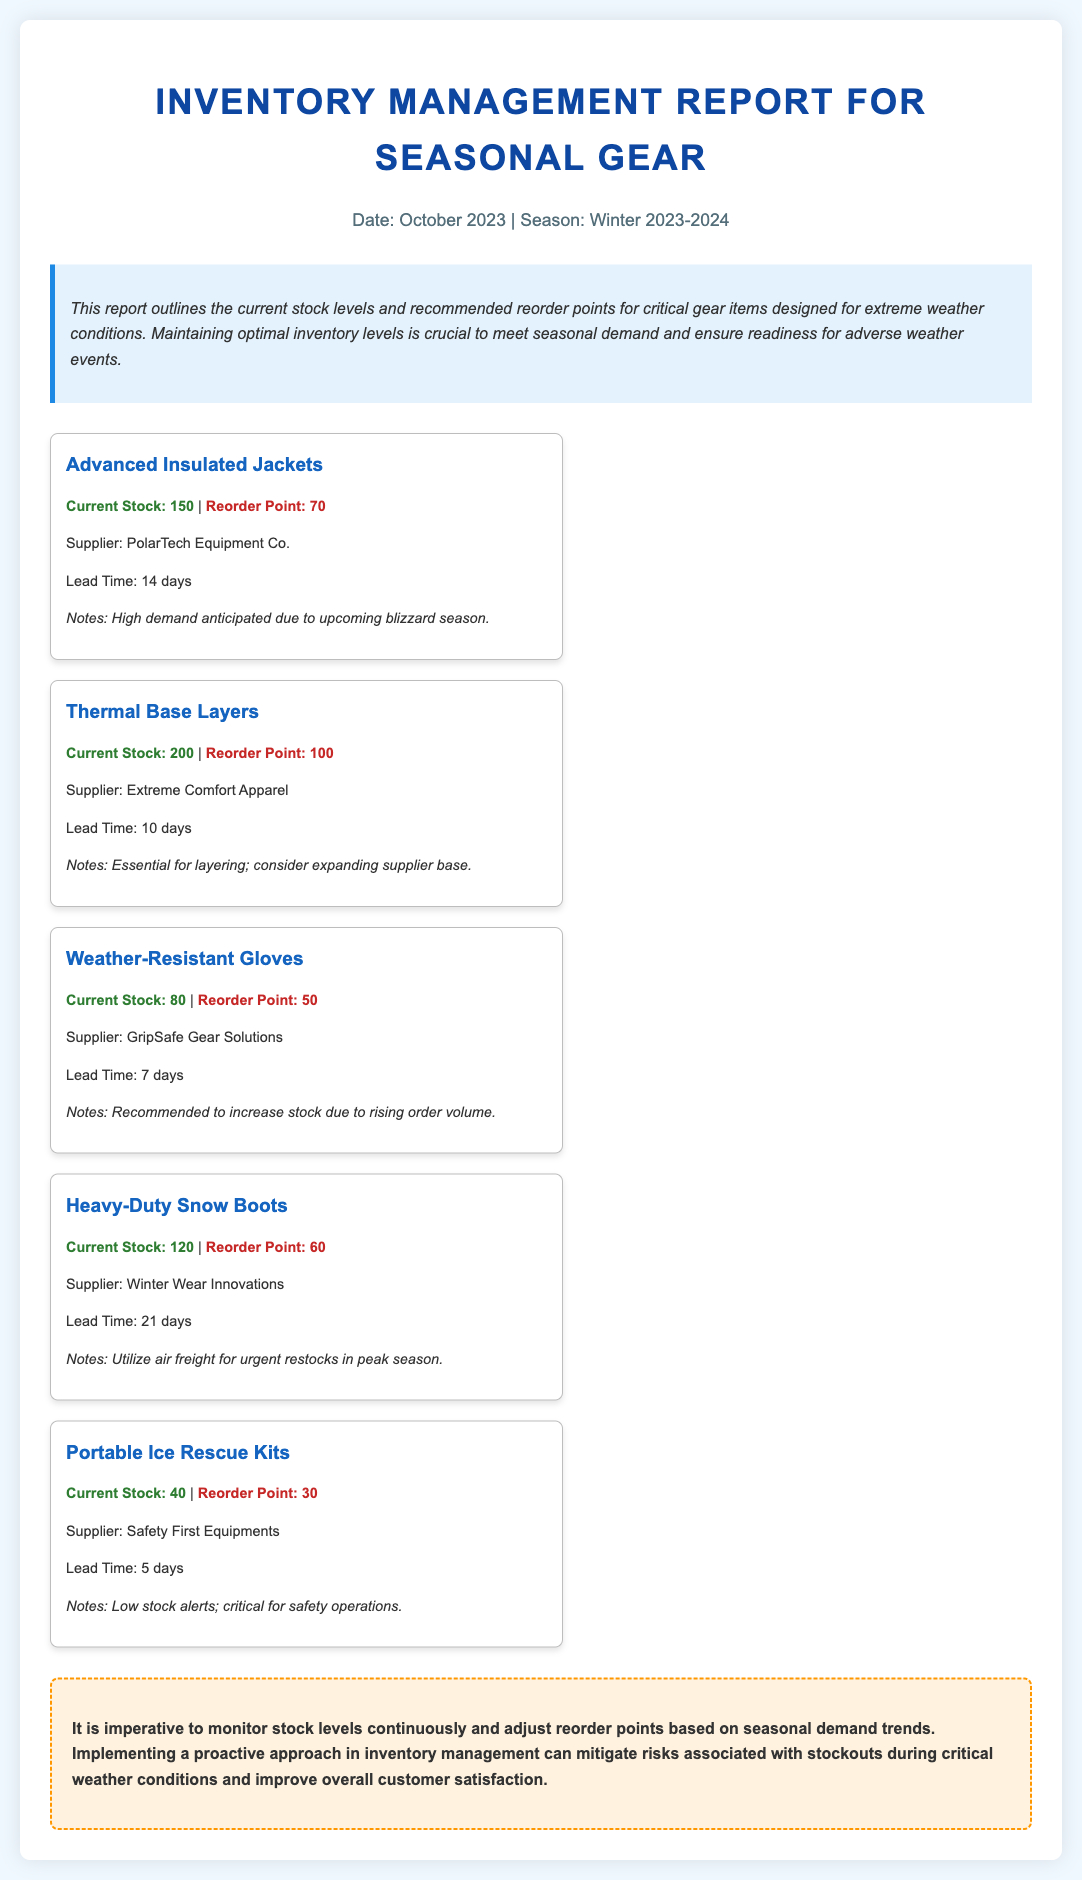what is the date of the report? The report was created in October 2023.
Answer: October 2023 what is the stock level for Advanced Insulated Jackets? The current stock level for Advanced Insulated Jackets is provided in the document.
Answer: 150 what is the reorder point for Portable Ice Rescue Kits? The reorder point for Portable Ice Rescue Kits is specified in the report.
Answer: 30 which supplier provides Thermal Base Layers? The document lists the supplier for Thermal Base Layers.
Answer: Extreme Comfort Apparel what is the lead time for Weather-Resistant Gloves? The lead time for Weather-Resistant Gloves is mentioned in the document.
Answer: 7 days how many units of Heavy-Duty Snow Boots are currently in stock? The stock level for Heavy-Duty Snow Boots is outlined in the report.
Answer: 120 which item has the lowest current stock level? This question requires comparing the stock levels of all items listed.
Answer: Portable Ice Rescue Kits what is the main purpose of this inventory report? The document explains the overall objective of the report in the overview section.
Answer: Outline stock levels and reorder points how should inventory levels be managed leading up to the winter season? The summary section provides insight into inventory management practices.
Answer: Monitor stock levels continuously 